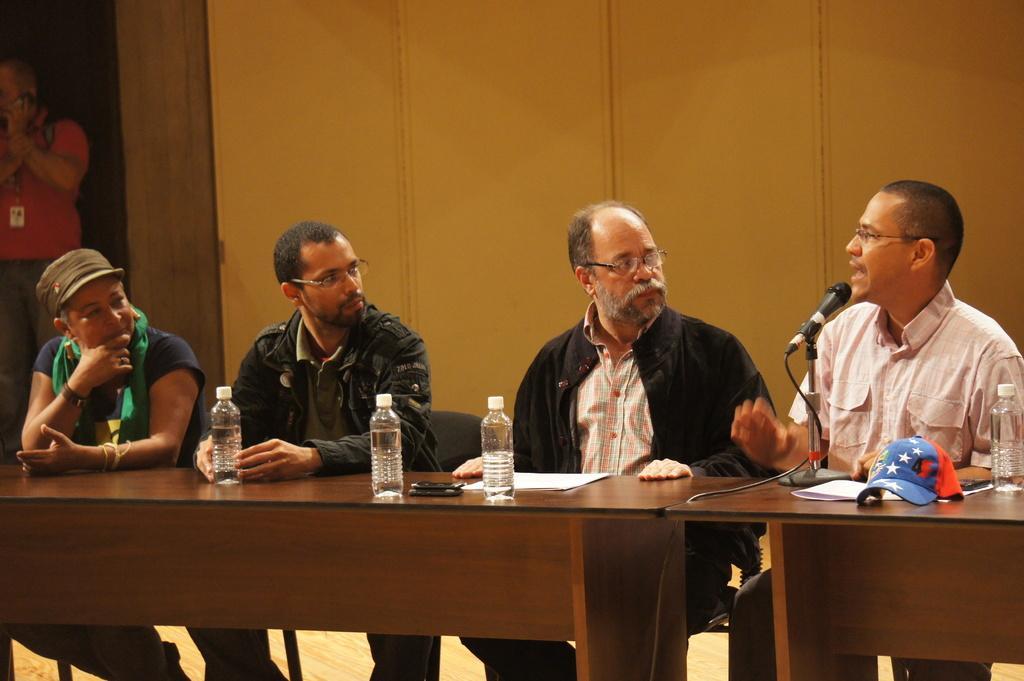How would you summarize this image in a sentence or two? Here we can see four persons are sitting on the chairs and he is talking on the mike. This is table. On the table there are bottles, cap, papers, and a mobile. This is floor. In the background we can see a wall and a person. 